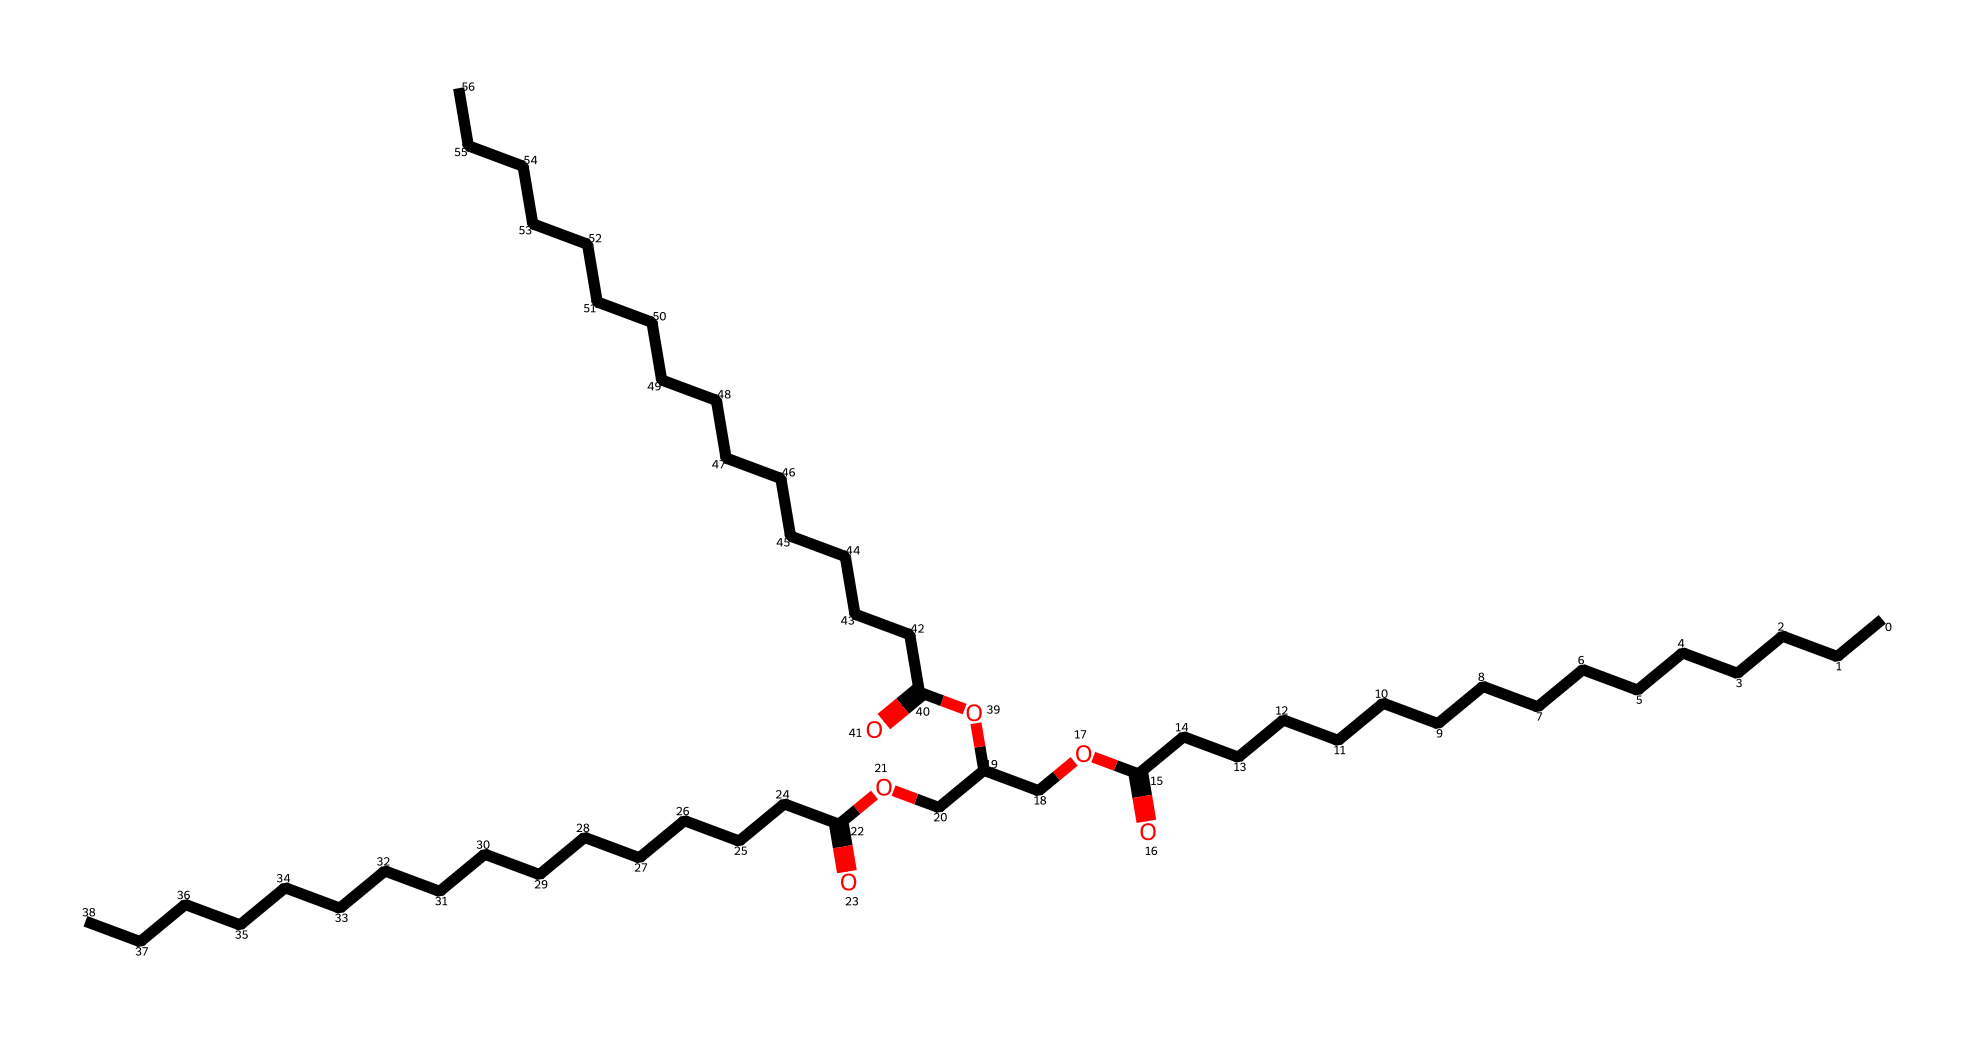What type of functional group is present in this chemical? This chemical contains a carboxylic acid group (-COOH) indicated by the presence of the -O(=O) and -OH (where O is double-bonded to C).
Answer: carboxylic acid How many carbon atoms are present in this chemical? By analyzing the structure, there are a total of 45 carbon atoms throughout the entire chemical structure.
Answer: 45 What is the main application of this chemical in traditional soap-making? This chemical structure exhibits properties of a lubricant, which makes it suitable for use in soaps to provide lubrication during application.
Answer: lubrication What type of lipid does this chemical represent? The structure features long fatty acid chains typical of triglycerides, which are commonly found in animal fats.
Answer: triglycerides How many ester bonds are present in this chemical? The chemical structure can be analyzed for ester linkages; counting indicates there are three ester bonds present in the structure.
Answer: three 